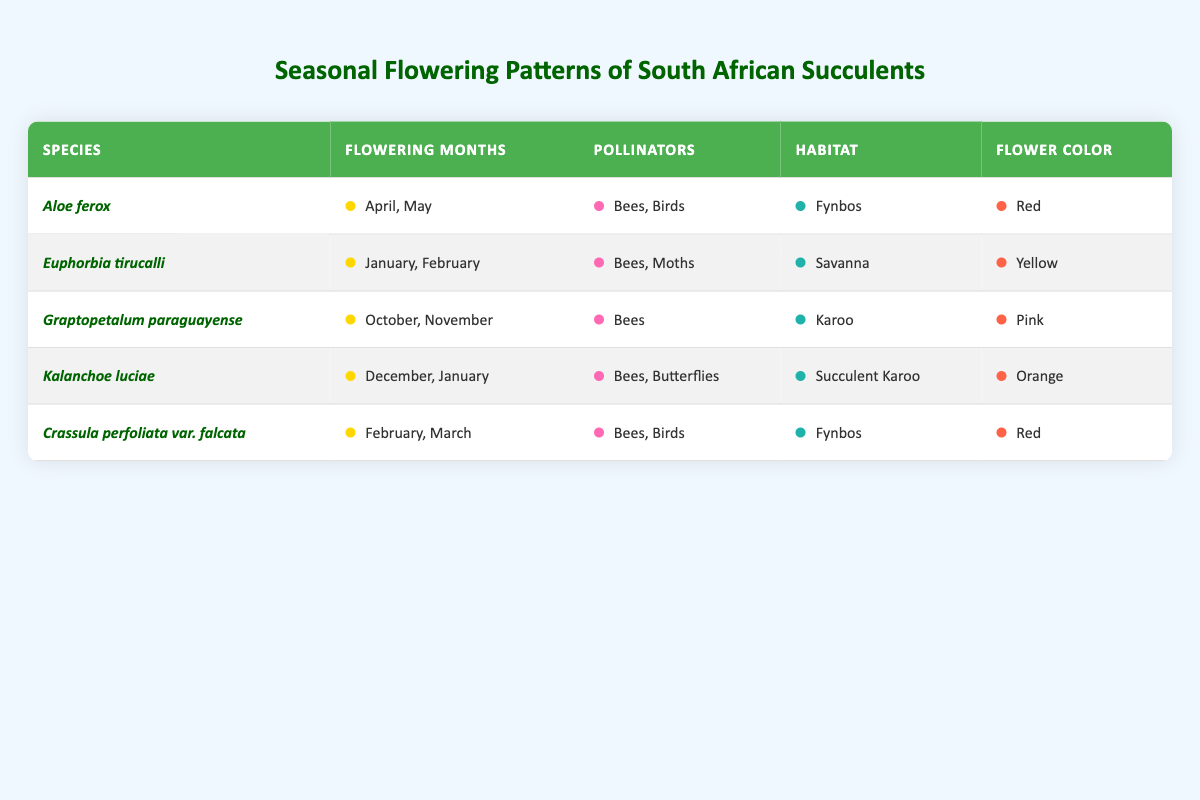What are the flowering months for Aloe ferox? The table lists Aloe ferox under the species column, and its corresponding flowering months are given in the flowering months column as "April, May".
Answer: April, May Which species have red flowers? By examining the flower color column, both Aloe ferox and Crassula perfoliata var. falcata are identified as having red flowers.
Answer: Aloe ferox, Crassula perfoliata var. falcata How many species flower in the months of January and February? The table reveals that Euphorbia tirucalli and Kalanchoe luciae are the only species that flower during January and February, totaling to two species.
Answer: 2 Do any species in the table have pollinators that include both bees and birds? Upon reviewing the pollinators listed, Aloe ferox and Crassula perfoliata var. falcata are shown to have both bees and birds as pollinators, thus answering yes to the question.
Answer: Yes What is the habitat of Graptopetalum paraguayense? Looking at the corresponding row for Graptopetalum paraguayense, it is listed under the habitat column as "Karoo".
Answer: Karoo How many different habitats are represented by the species in the table? Upon inspecting each species' habitat, there are five unique habitats: Fynbos, Savanna, Karoo, Succulent Karoo, and Fynbos. This indicates a total of four unique habitats since Fynbos is repeated.
Answer: 4 Which species is the only one pollinated solely by bees? Reviewing the pollinators for each species, Graptopetalum paraguayense is indicated as being pollinated only by bees, fulfilling the requirement of the question.
Answer: Graptopetalum paraguayense What is the average number of months that species flower in this table? To calculate the average, we first sum the total flowering months (2 for Aloe ferox, 2 for Euphorbia tirucalli, 2 for Graptopetalum paraguayense, 2 for Kalanchoe luciae, and 2 for Crassula perfoliata var. falcata), getting a total of 10 months. There are 5 species, so the average is 10 divided by 5, equaling 2.
Answer: 2 